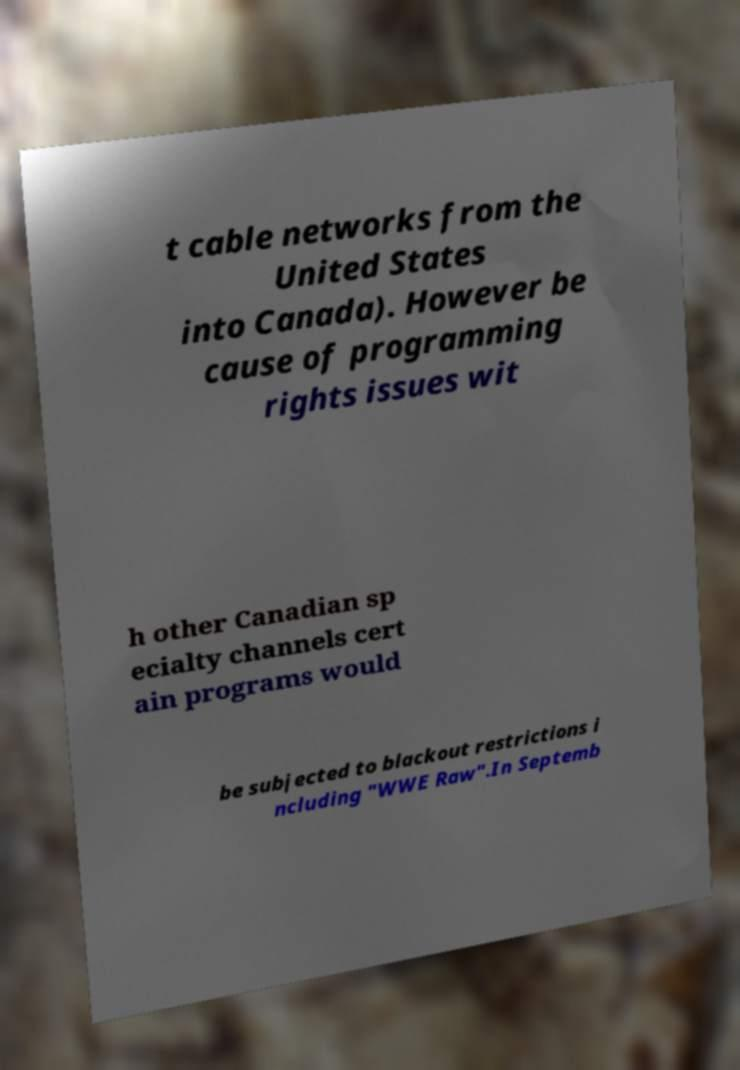For documentation purposes, I need the text within this image transcribed. Could you provide that? t cable networks from the United States into Canada). However be cause of programming rights issues wit h other Canadian sp ecialty channels cert ain programs would be subjected to blackout restrictions i ncluding "WWE Raw".In Septemb 